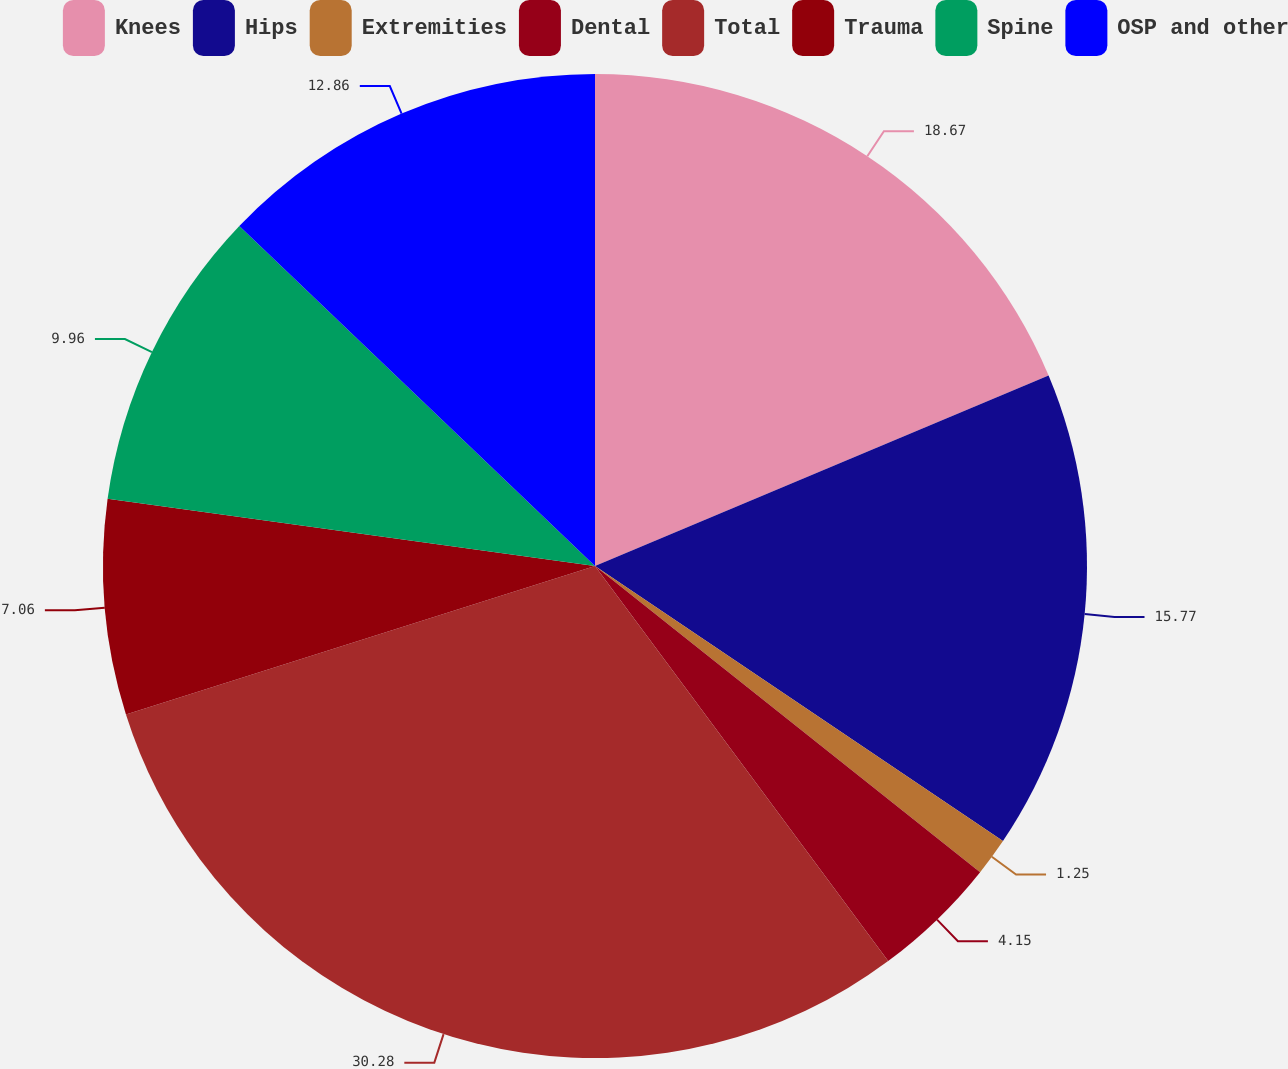Convert chart. <chart><loc_0><loc_0><loc_500><loc_500><pie_chart><fcel>Knees<fcel>Hips<fcel>Extremities<fcel>Dental<fcel>Total<fcel>Trauma<fcel>Spine<fcel>OSP and other<nl><fcel>18.67%<fcel>15.77%<fcel>1.25%<fcel>4.15%<fcel>30.28%<fcel>7.06%<fcel>9.96%<fcel>12.86%<nl></chart> 